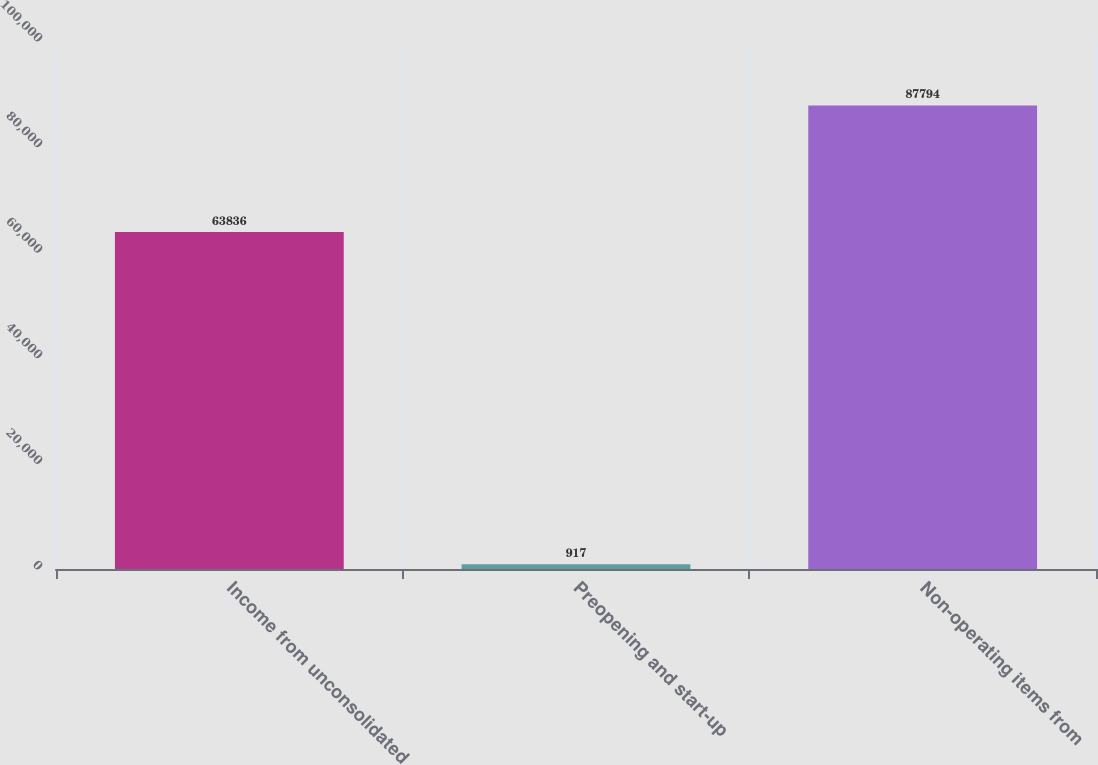Convert chart to OTSL. <chart><loc_0><loc_0><loc_500><loc_500><bar_chart><fcel>Income from unconsolidated<fcel>Preopening and start-up<fcel>Non-operating items from<nl><fcel>63836<fcel>917<fcel>87794<nl></chart> 